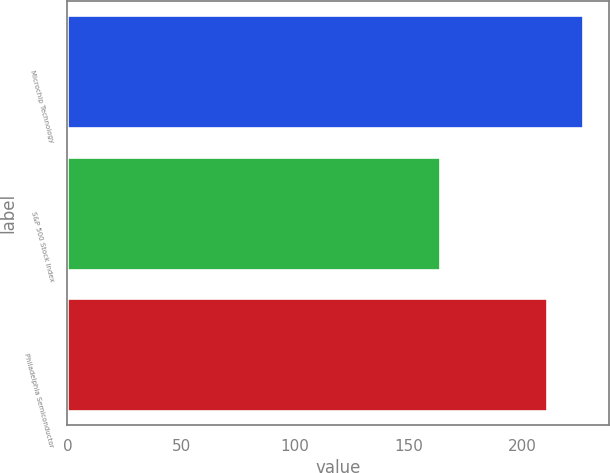Convert chart to OTSL. <chart><loc_0><loc_0><loc_500><loc_500><bar_chart><fcel>Microchip Technology<fcel>S&P 500 Stock Index<fcel>Philadelphia Semiconductor<nl><fcel>226.37<fcel>163.83<fcel>210.77<nl></chart> 